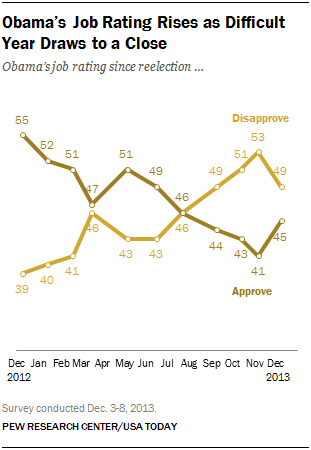Identify some key points in this picture. The highest disapproval of Obama's job rating was 53%. In December 2013, the ratio of disapproval to approval of Obama's job performance was 1.088889... 